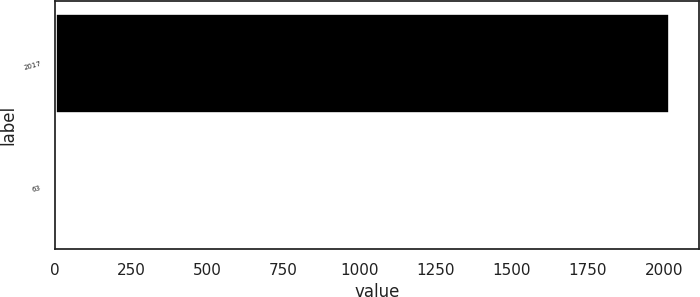<chart> <loc_0><loc_0><loc_500><loc_500><bar_chart><fcel>2017<fcel>63<nl><fcel>2016<fcel>1<nl></chart> 